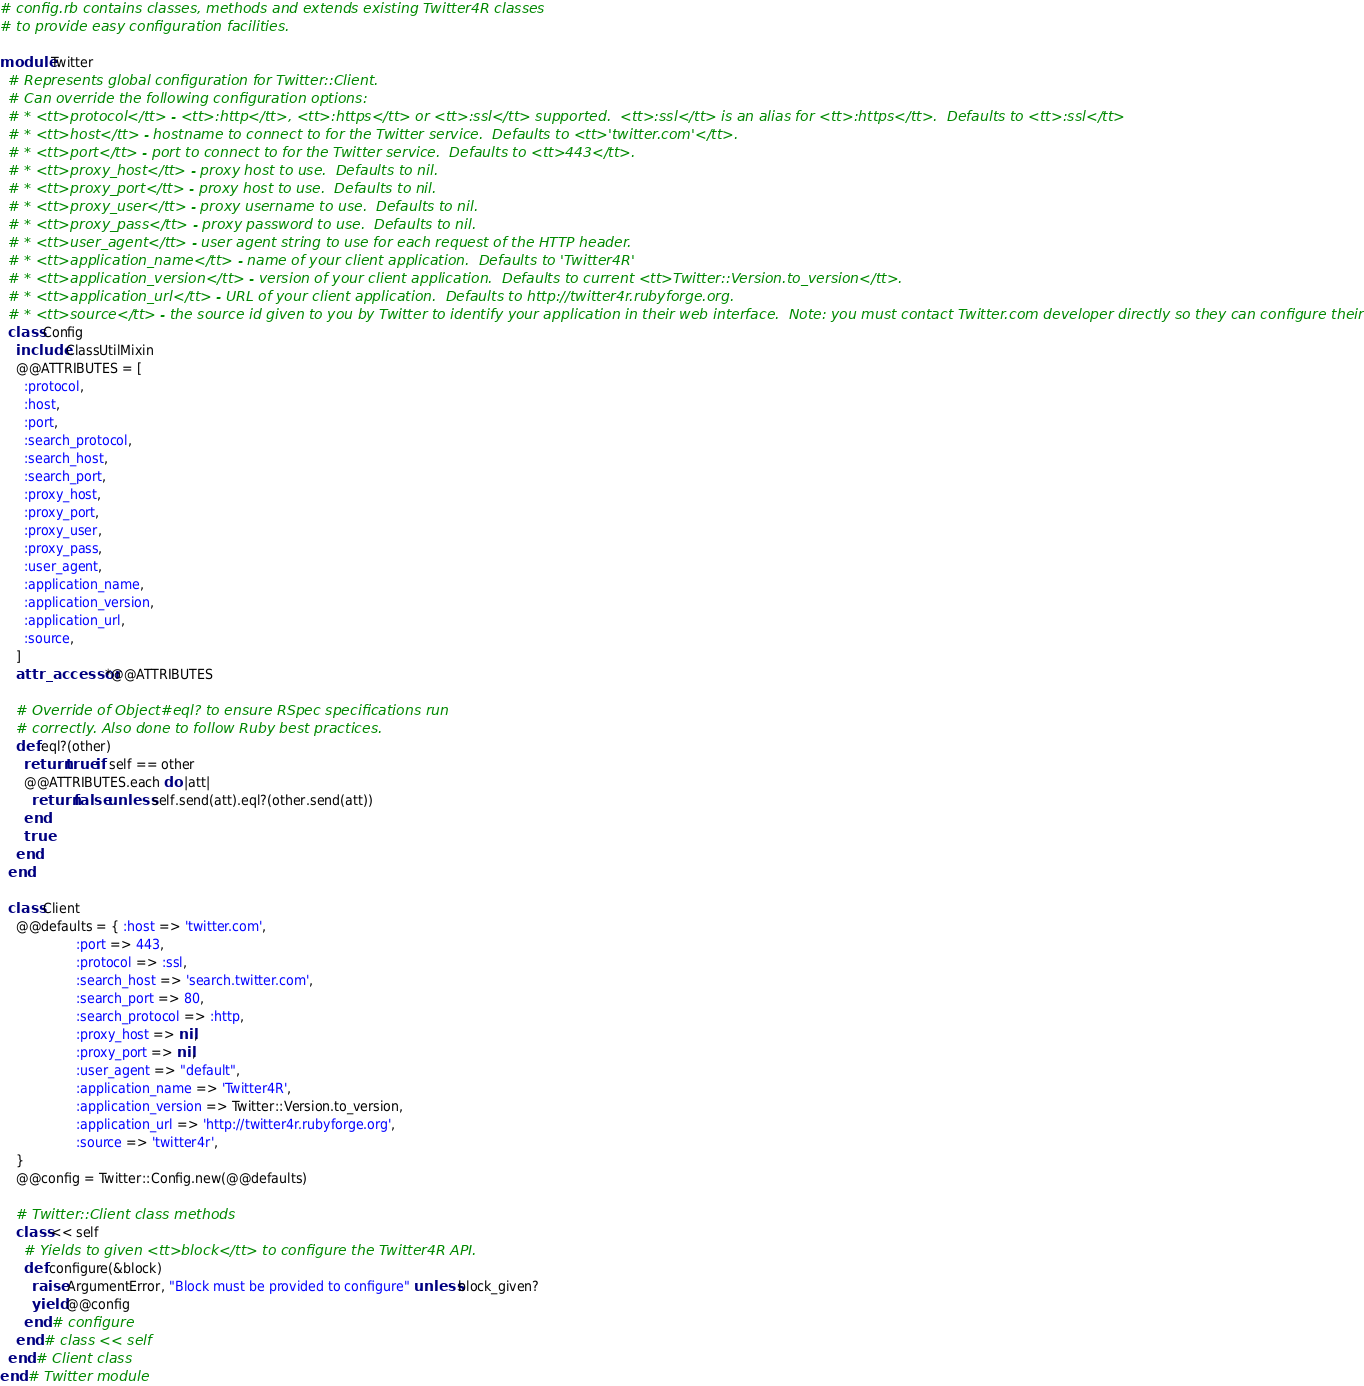Convert code to text. <code><loc_0><loc_0><loc_500><loc_500><_Ruby_># config.rb contains classes, methods and extends existing Twitter4R classes
# to provide easy configuration facilities.

module Twitter
  # Represents global configuration for Twitter::Client.
  # Can override the following configuration options:
  # * <tt>protocol</tt> - <tt>:http</tt>, <tt>:https</tt> or <tt>:ssl</tt> supported.  <tt>:ssl</tt> is an alias for <tt>:https</tt>.  Defaults to <tt>:ssl</tt>
  # * <tt>host</tt> - hostname to connect to for the Twitter service.  Defaults to <tt>'twitter.com'</tt>.
  # * <tt>port</tt> - port to connect to for the Twitter service.  Defaults to <tt>443</tt>.
  # * <tt>proxy_host</tt> - proxy host to use.  Defaults to nil.
  # * <tt>proxy_port</tt> - proxy host to use.  Defaults to nil.
  # * <tt>proxy_user</tt> - proxy username to use.  Defaults to nil.
  # * <tt>proxy_pass</tt> - proxy password to use.  Defaults to nil.
  # * <tt>user_agent</tt> - user agent string to use for each request of the HTTP header.
  # * <tt>application_name</tt> - name of your client application.  Defaults to 'Twitter4R'
  # * <tt>application_version</tt> - version of your client application.  Defaults to current <tt>Twitter::Version.to_version</tt>.
  # * <tt>application_url</tt> - URL of your client application.  Defaults to http://twitter4r.rubyforge.org.
  # * <tt>source</tt> - the source id given to you by Twitter to identify your application in their web interface.  Note: you must contact Twitter.com developer directly so they can configure their servers appropriately.
  class Config
    include ClassUtilMixin
    @@ATTRIBUTES = [
      :protocol,
      :host,
      :port,
      :search_protocol,
      :search_host,
      :search_port,
      :proxy_host,
      :proxy_port,
      :proxy_user,
      :proxy_pass,
      :user_agent,
      :application_name,
      :application_version,
      :application_url,
      :source,
    ]
    attr_accessor *@@ATTRIBUTES

    # Override of Object#eql? to ensure RSpec specifications run
    # correctly. Also done to follow Ruby best practices.
    def eql?(other)
      return true if self == other
      @@ATTRIBUTES.each do |att|
        return false unless self.send(att).eql?(other.send(att))
      end
      true
    end
  end

  class Client
    @@defaults = { :host => 'twitter.com',
                   :port => 443,
                   :protocol => :ssl,
                   :search_host => 'search.twitter.com',
                   :search_port => 80,
                   :search_protocol => :http,
                   :proxy_host => nil,
                   :proxy_port => nil,
                   :user_agent => "default",
                   :application_name => 'Twitter4R',
                   :application_version => Twitter::Version.to_version,
                   :application_url => 'http://twitter4r.rubyforge.org',
                   :source => 'twitter4r',
    }
    @@config = Twitter::Config.new(@@defaults)

    # Twitter::Client class methods
    class << self
      # Yields to given <tt>block</tt> to configure the Twitter4R API.
      def configure(&block)
        raise ArgumentError, "Block must be provided to configure" unless block_given?
        yield @@config
      end # configure
    end # class << self
  end # Client class
end # Twitter module
</code> 